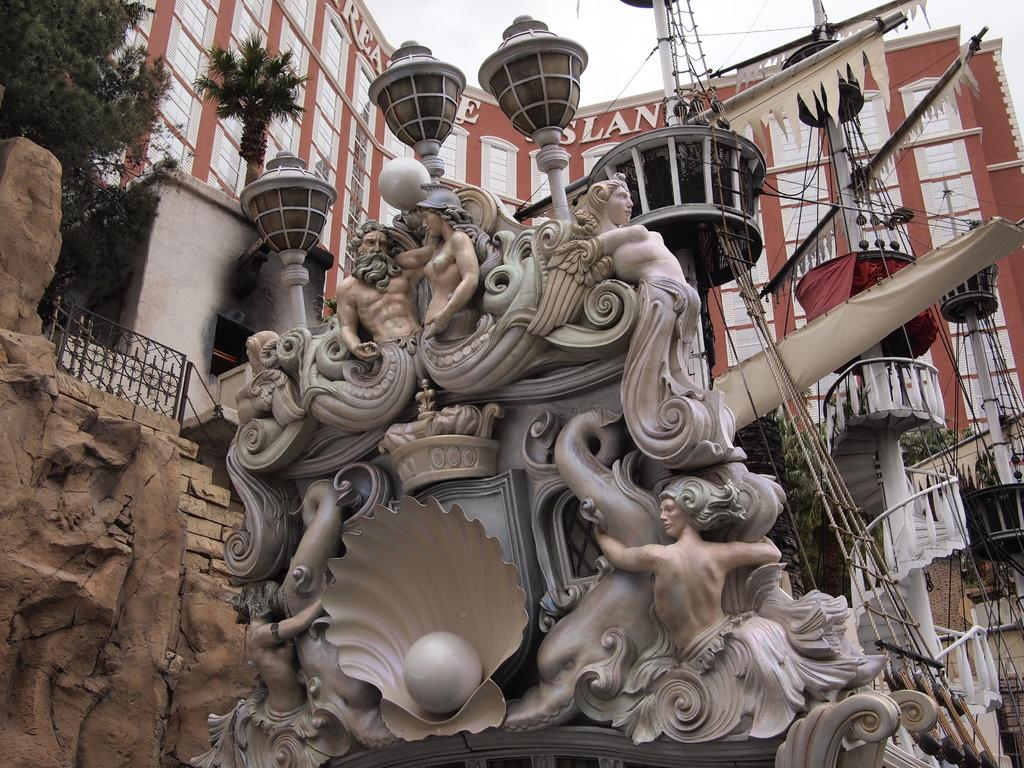What is located in the center of the image? There are statues, ropes, and lights in the center of the image. What other objects can be seen in the center of the image? There are other objects in the center of the image. What is visible in the background of the image? There are buildings and plants in the background of the image. Can you tell me how many ducks are sitting on the statues in the image? There are no ducks present in the image; it features statues, ropes, and lights in the center, with buildings and plants in the background. What type of health advice can be seen on the statues in the image? There is no health advice present on the statues in the image; they are simply statues with no visible text or information. 